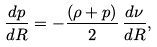Convert formula to latex. <formula><loc_0><loc_0><loc_500><loc_500>\frac { d p } { d R } = - \frac { \left ( \rho + p \right ) } { 2 } \, \frac { d \nu } { d R } ,</formula> 